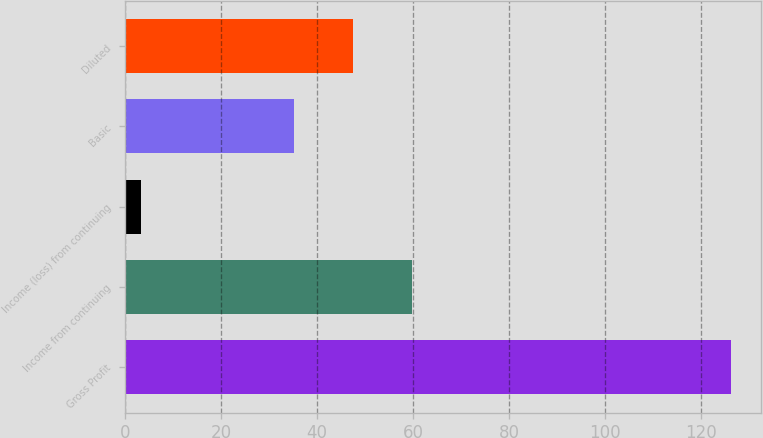Convert chart to OTSL. <chart><loc_0><loc_0><loc_500><loc_500><bar_chart><fcel>Gross Profit<fcel>Income from continuing<fcel>Income (loss) from continuing<fcel>Basic<fcel>Diluted<nl><fcel>126.1<fcel>59.74<fcel>3.4<fcel>35.2<fcel>47.47<nl></chart> 